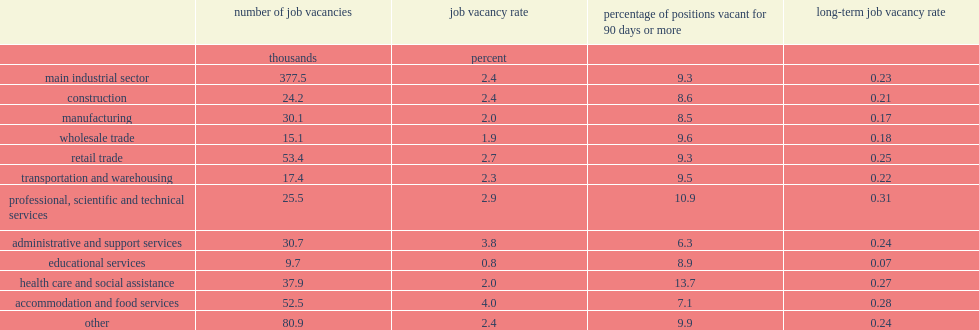In 2016, what are the top two main industrial sectors that had the highest prevalence of long-term job vacancies? Professional, scientific and technical services health care and social assistance. Which main industrial sector has posted the highest long-term job vacancy rate? Professional, scientific and technical services. Which main industrial sector has the lowest long-term vacancy rate? Educational services. Could you help me parse every detail presented in this table? {'header': ['', 'number of job vacancies', 'job vacancy rate', 'percentage of positions vacant for 90 days or more', 'long-term job vacancy rate'], 'rows': [['', 'thousands', 'percent', '', ''], ['main industrial sector', '377.5', '2.4', '9.3', '0.23'], ['construction', '24.2', '2.4', '8.6', '0.21'], ['manufacturing', '30.1', '2.0', '8.5', '0.17'], ['wholesale trade', '15.1', '1.9', '9.6', '0.18'], ['retail trade', '53.4', '2.7', '9.3', '0.25'], ['transportation and warehousing', '17.4', '2.3', '9.5', '0.22'], ['professional, scientific and technical services', '25.5', '2.9', '10.9', '0.31'], ['administrative and support services', '30.7', '3.8', '6.3', '0.24'], ['educational services', '9.7', '0.8', '8.9', '0.07'], ['health care and social assistance', '37.9', '2.0', '13.7', '0.27'], ['accommodation and food services', '52.5', '4.0', '7.1', '0.28'], ['other', '80.9', '2.4', '9.9', '0.24']]} 